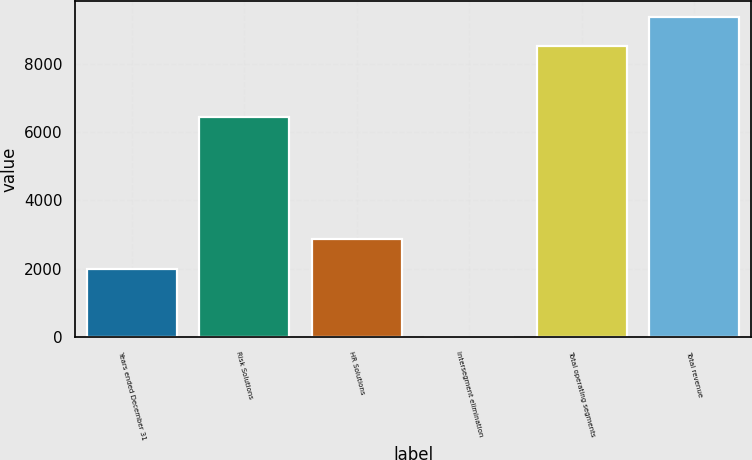<chart> <loc_0><loc_0><loc_500><loc_500><bar_chart><fcel>Years ended December 31<fcel>Risk Solutions<fcel>HR Solutions<fcel>Intersegment elimination<fcel>Total operating segments<fcel>Total revenue<nl><fcel>2010<fcel>6423<fcel>2859<fcel>22<fcel>8512<fcel>9361<nl></chart> 